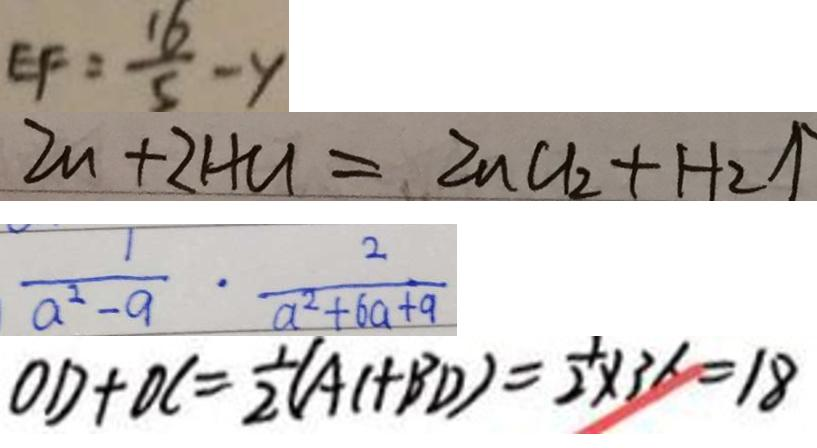<formula> <loc_0><loc_0><loc_500><loc_500>E F = \frac { 1 6 } { 5 } - y 
 Z n + 2 H C l = Z n C l _ { 2 } + H _ { 2 } \uparrow 
 \frac { 1 } { a ^ { 2 } - 9 } \cdot \frac { 2 } { a ^ { 2 } + 6 a + 9 } 
 O D + D C = \frac { 1 } { 2 } ( A C + B D ) = \frac { 1 } { 2 } \times 3 6 = 1 8</formula> 